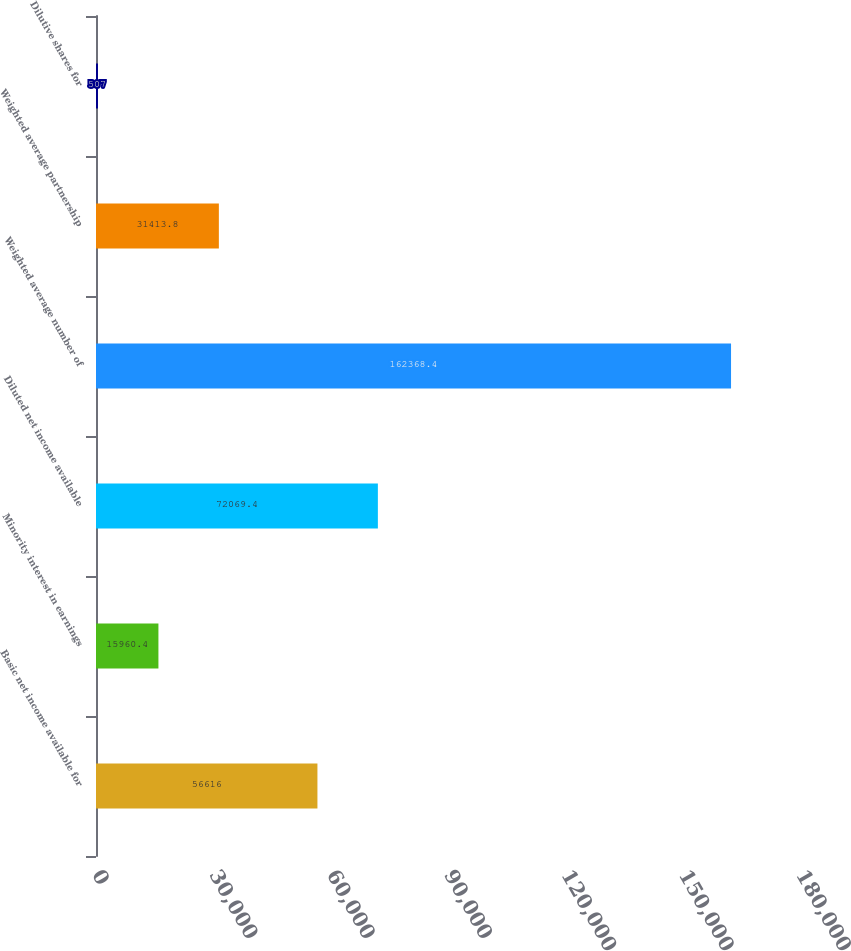Convert chart to OTSL. <chart><loc_0><loc_0><loc_500><loc_500><bar_chart><fcel>Basic net income available for<fcel>Minority interest in earnings<fcel>Diluted net income available<fcel>Weighted average number of<fcel>Weighted average partnership<fcel>Dilutive shares for<nl><fcel>56616<fcel>15960.4<fcel>72069.4<fcel>162368<fcel>31413.8<fcel>507<nl></chart> 